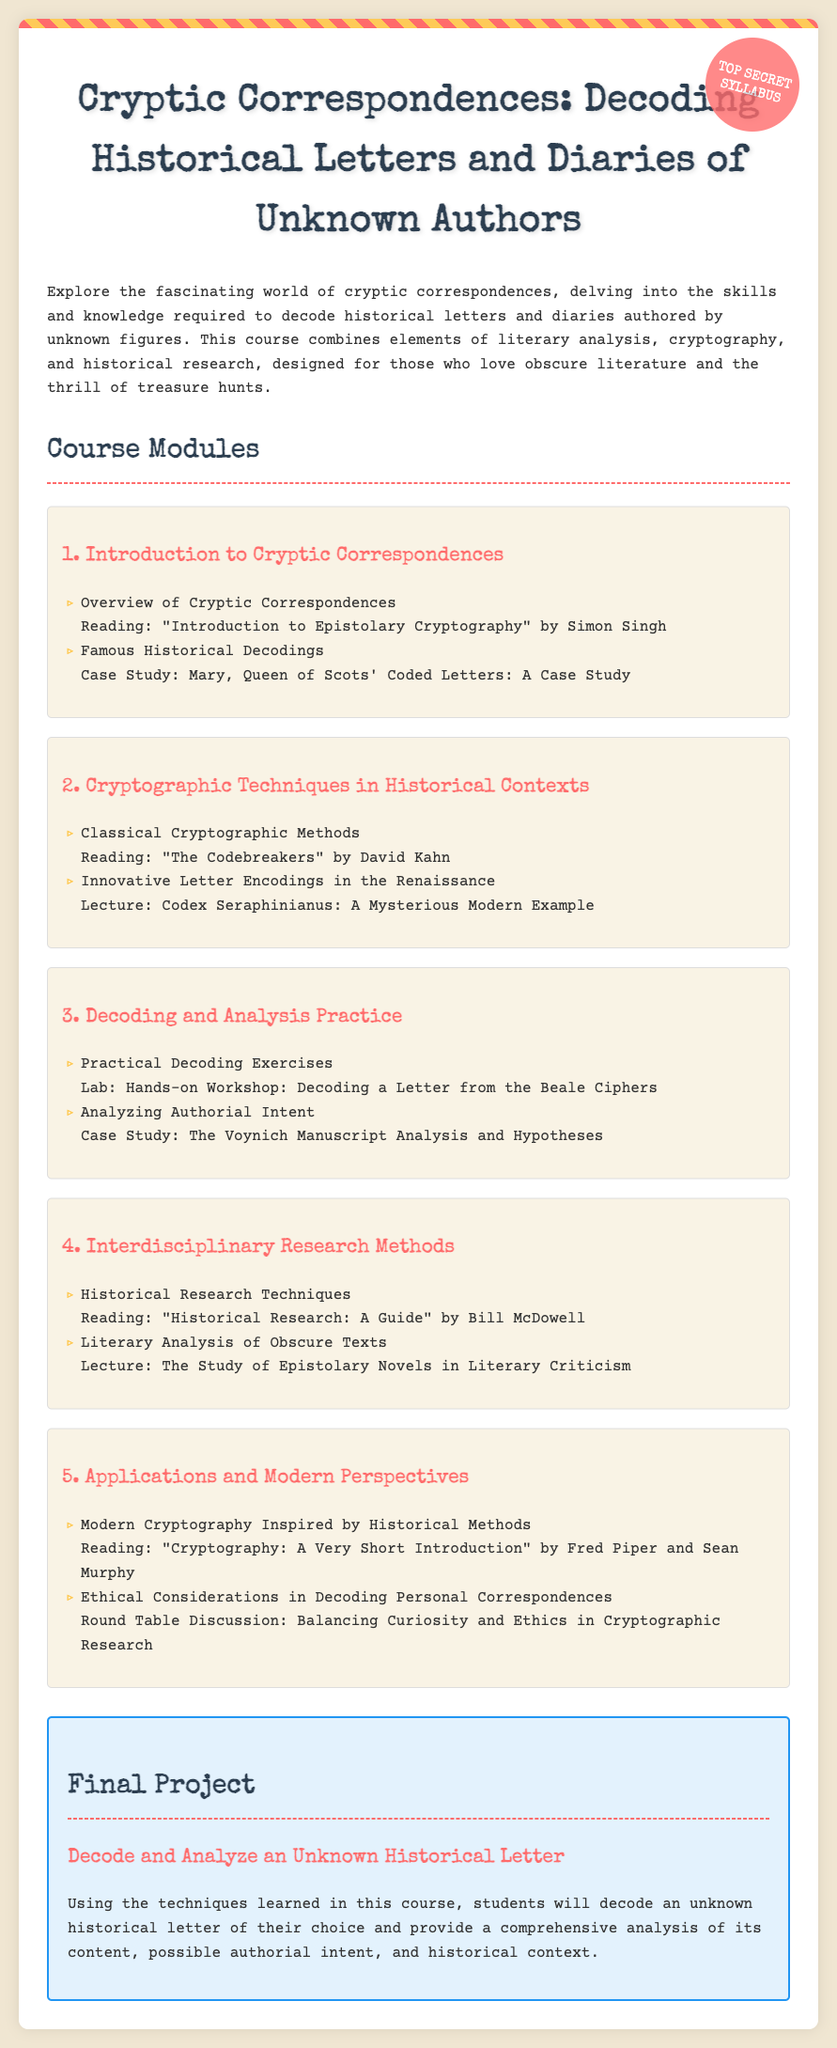What is the title of the syllabus? The title is clearly stated at the top of the syllabus, focusing on cryptic correspondences.
Answer: Cryptic Correspondences: Decoding Historical Letters and Diaries of Unknown Authors How many modules are in the course? The syllabus lists a total of five distinct modules covering various topics.
Answer: 5 Who is the author of the recommended reading "The Codebreakers"? The syllabus specifically names David Kahn as the author of this reading.
Answer: David Kahn What is the final project about? The final project is described as decoding and analyzing an unknown historical letter, integrating learned techniques.
Answer: Decode and Analyze an Unknown Historical Letter Which historical figure's coded letters are used as a case study? The syllabus mentions a specific historical figure known for her coded letters, providing an insightful example.
Answer: Mary, Queen of Scots What is the purpose of the round table discussion in module 5? The round table discussion focuses on a specific aspect of cryptographic research concerning discretion and ethics.
Answer: Balancing Curiosity and Ethics in Cryptographic Research What is the theme of the lecture in module 4? The lecture topic is about the study of a specific genre of novels and its relevance in literary analysis.
Answer: The Study of Epistolary Novels in Literary Criticism Which reading is assigned for historical research techniques? The syllabus provides a title that serves as a guide for conducting historical research effectively.
Answer: Historical Research: A Guide 